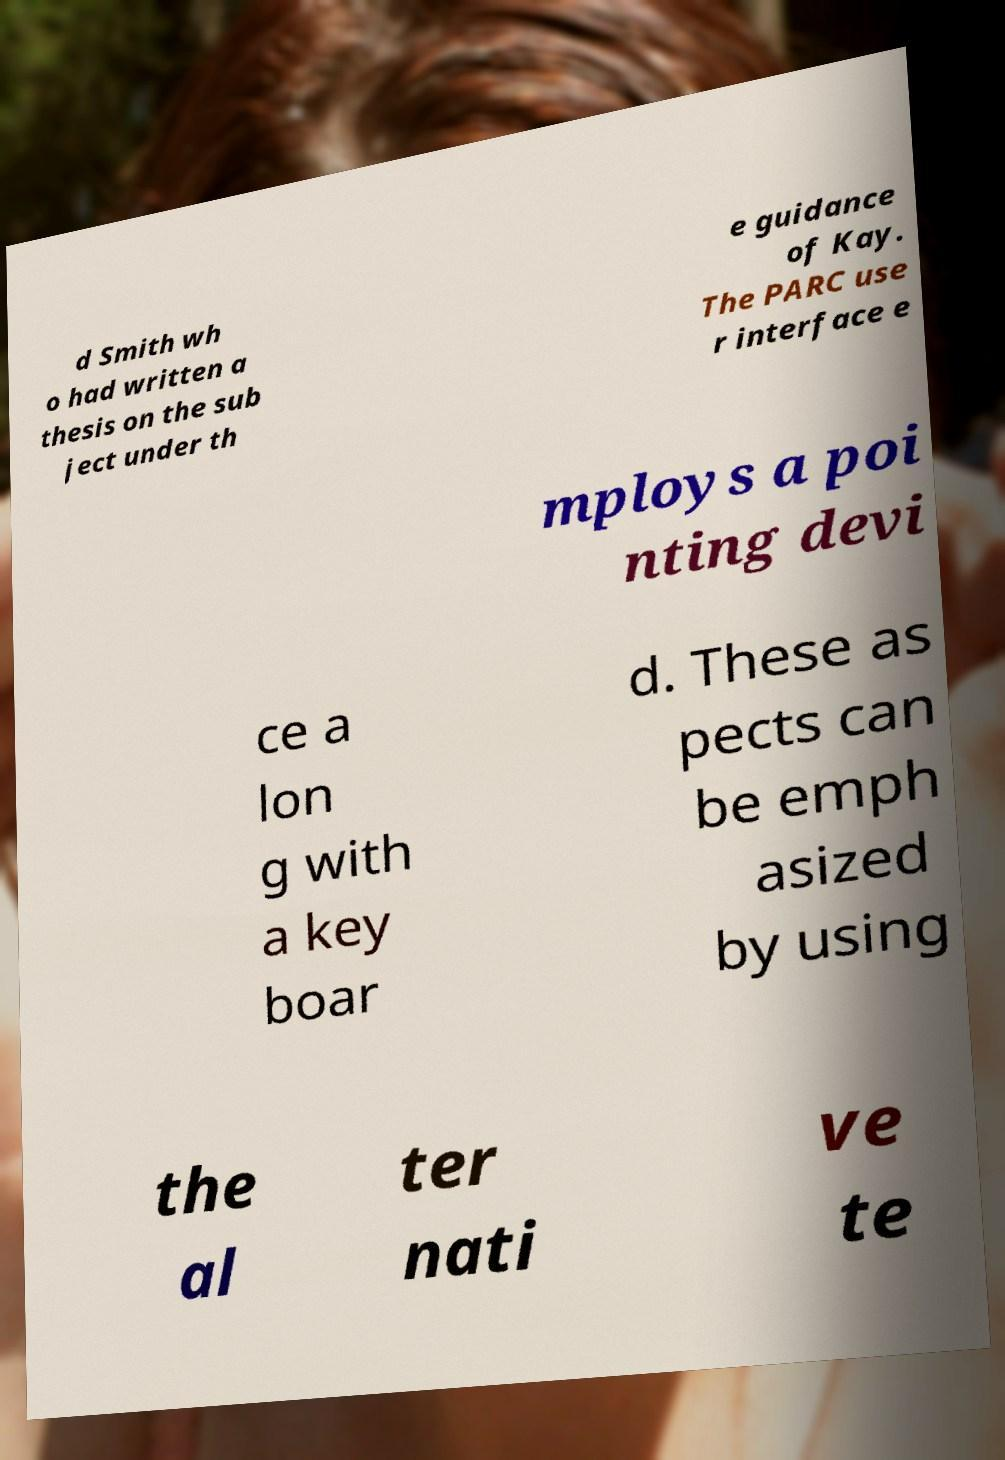There's text embedded in this image that I need extracted. Can you transcribe it verbatim? d Smith wh o had written a thesis on the sub ject under th e guidance of Kay. The PARC use r interface e mploys a poi nting devi ce a lon g with a key boar d. These as pects can be emph asized by using the al ter nati ve te 